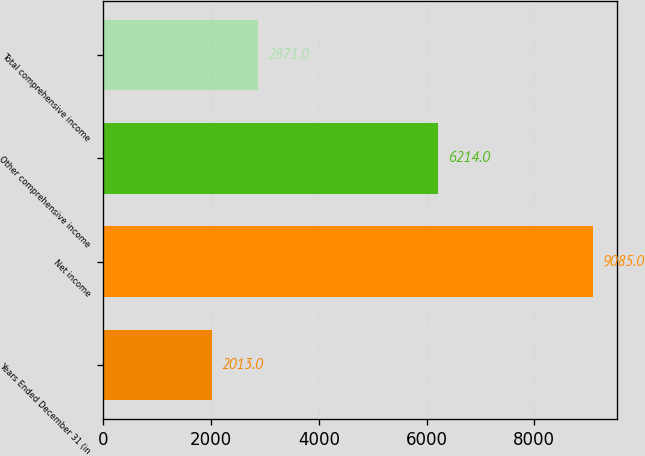Convert chart. <chart><loc_0><loc_0><loc_500><loc_500><bar_chart><fcel>Years Ended December 31 (in<fcel>Net income<fcel>Other comprehensive income<fcel>Total comprehensive income<nl><fcel>2013<fcel>9085<fcel>6214<fcel>2871<nl></chart> 